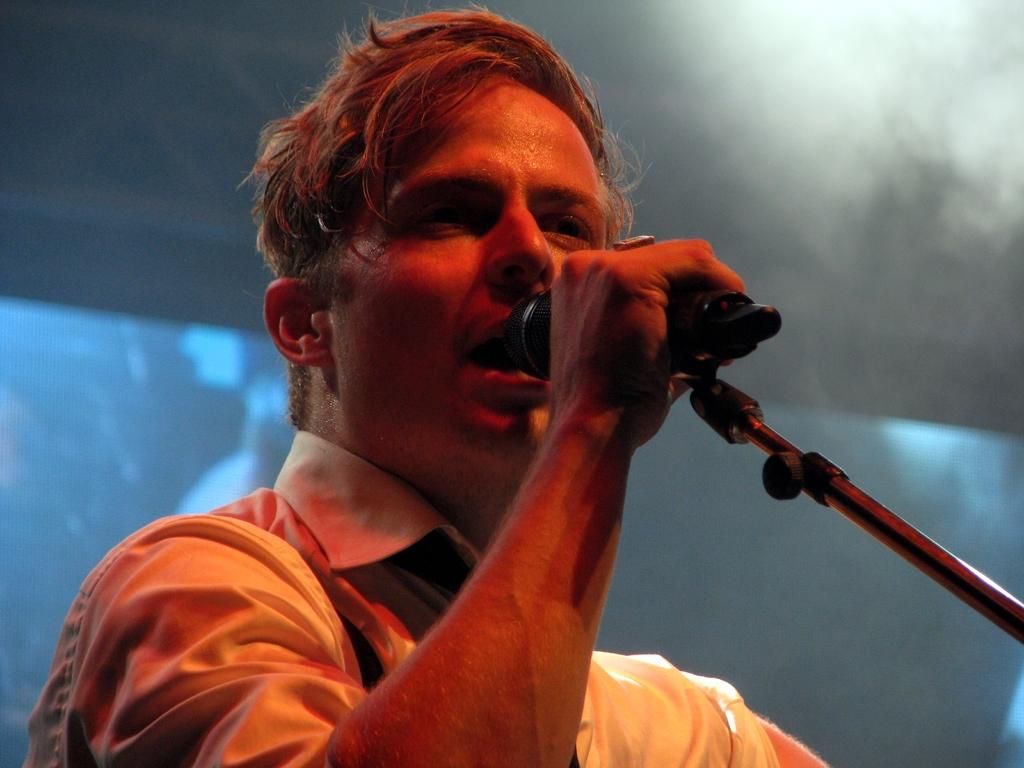Who is the main subject in the image? There is a man in the center of the image. What is the man holding in the image? The man is holding a mic. What can be seen in the background of the image? There is a screen in the background of the image. What type of cracker is the man eating in the image? There is no cracker present in the image; the man is holding a mic. Is the man taking a test in the image? There is no indication in the image that the man is taking a test. 